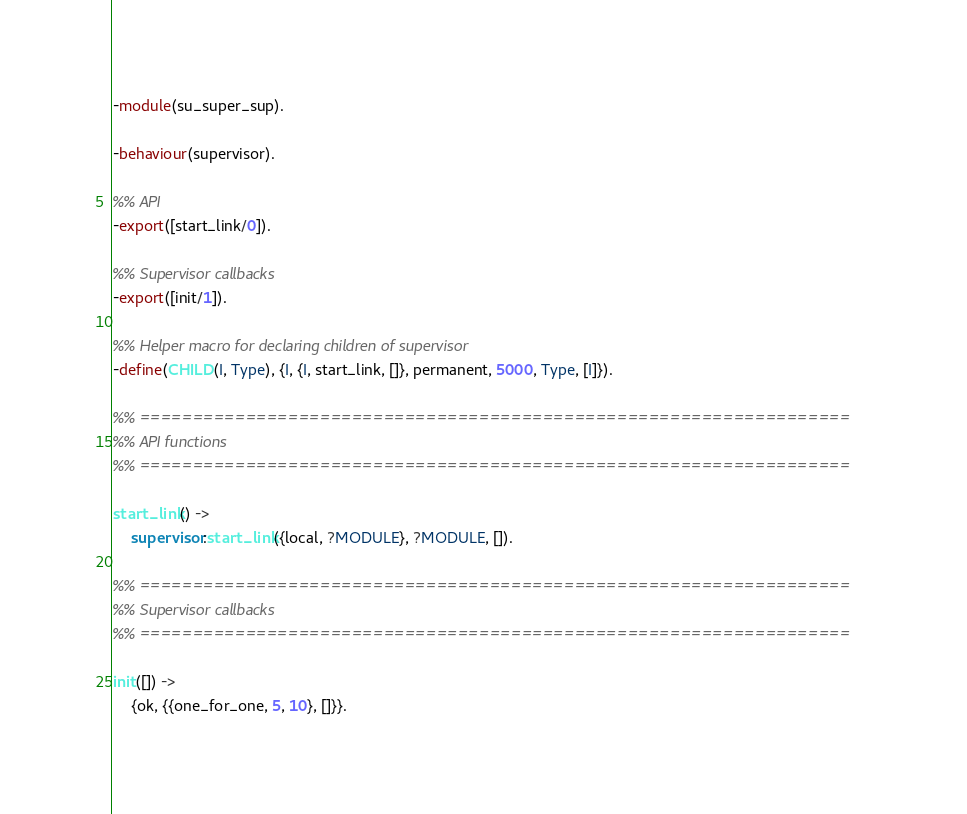<code> <loc_0><loc_0><loc_500><loc_500><_Erlang_>-module(su_super_sup).

-behaviour(supervisor).

%% API
-export([start_link/0]).

%% Supervisor callbacks
-export([init/1]).

%% Helper macro for declaring children of supervisor
-define(CHILD(I, Type), {I, {I, start_link, []}, permanent, 5000, Type, [I]}).

%% ===================================================================
%% API functions
%% ===================================================================

start_link() ->
	supervisor:start_link({local, ?MODULE}, ?MODULE, []).

%% ===================================================================
%% Supervisor callbacks
%% ===================================================================

init([]) ->
	{ok, {{one_for_one, 5, 10}, []}}.

</code> 